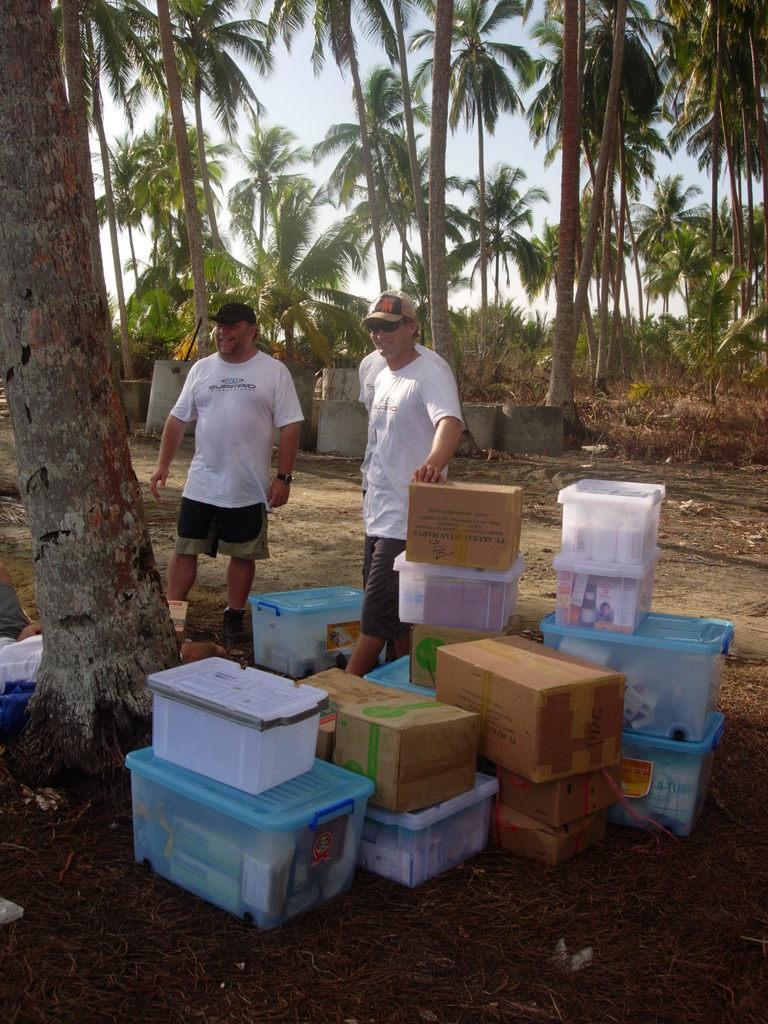How would you summarize this image in a sentence or two? In the foreground of this image, there are baskets and the cardboard boxes on the ground. Behind the boxes, there are three men standing on the ground. In the background, there are trees, cement cylinders and the sky. 